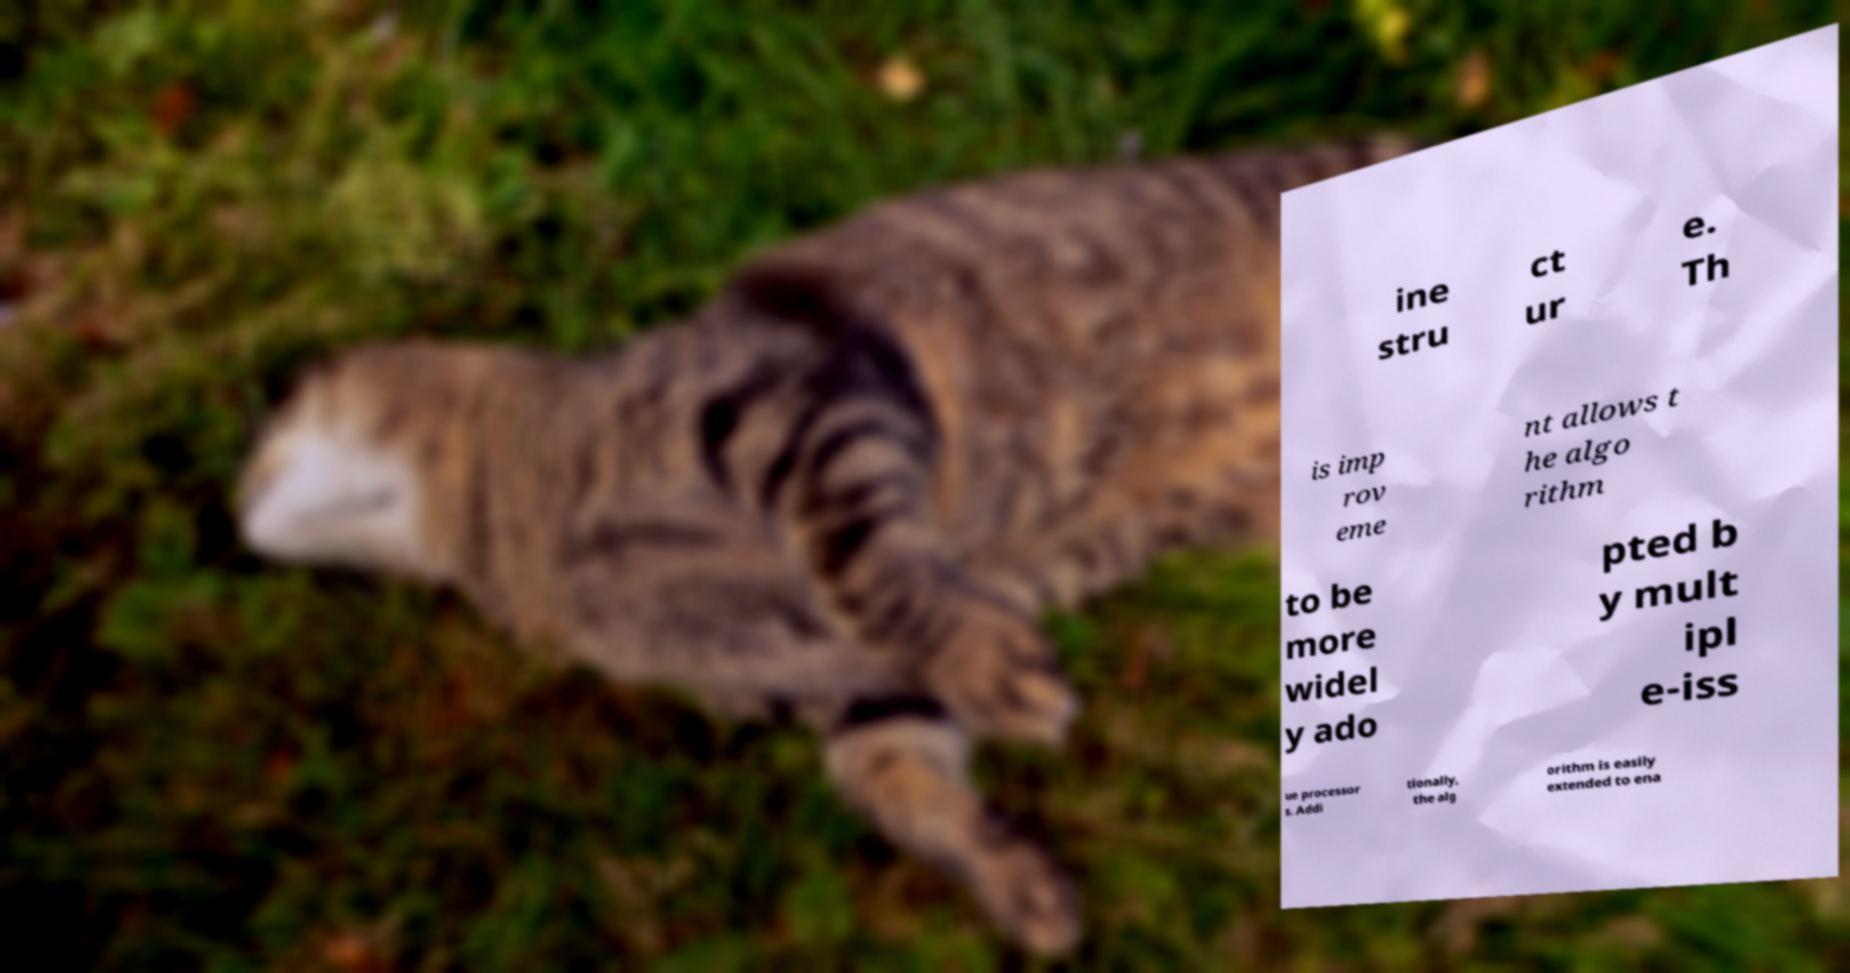Please read and relay the text visible in this image. What does it say? ine stru ct ur e. Th is imp rov eme nt allows t he algo rithm to be more widel y ado pted b y mult ipl e-iss ue processor s. Addi tionally, the alg orithm is easily extended to ena 